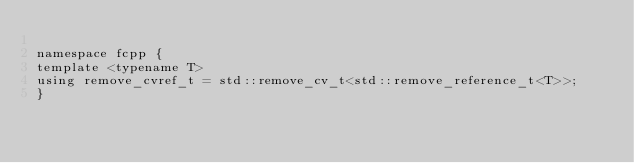Convert code to text. <code><loc_0><loc_0><loc_500><loc_500><_C_>
namespace fcpp {
template <typename T>
using remove_cvref_t = std::remove_cv_t<std::remove_reference_t<T>>;
}
</code> 